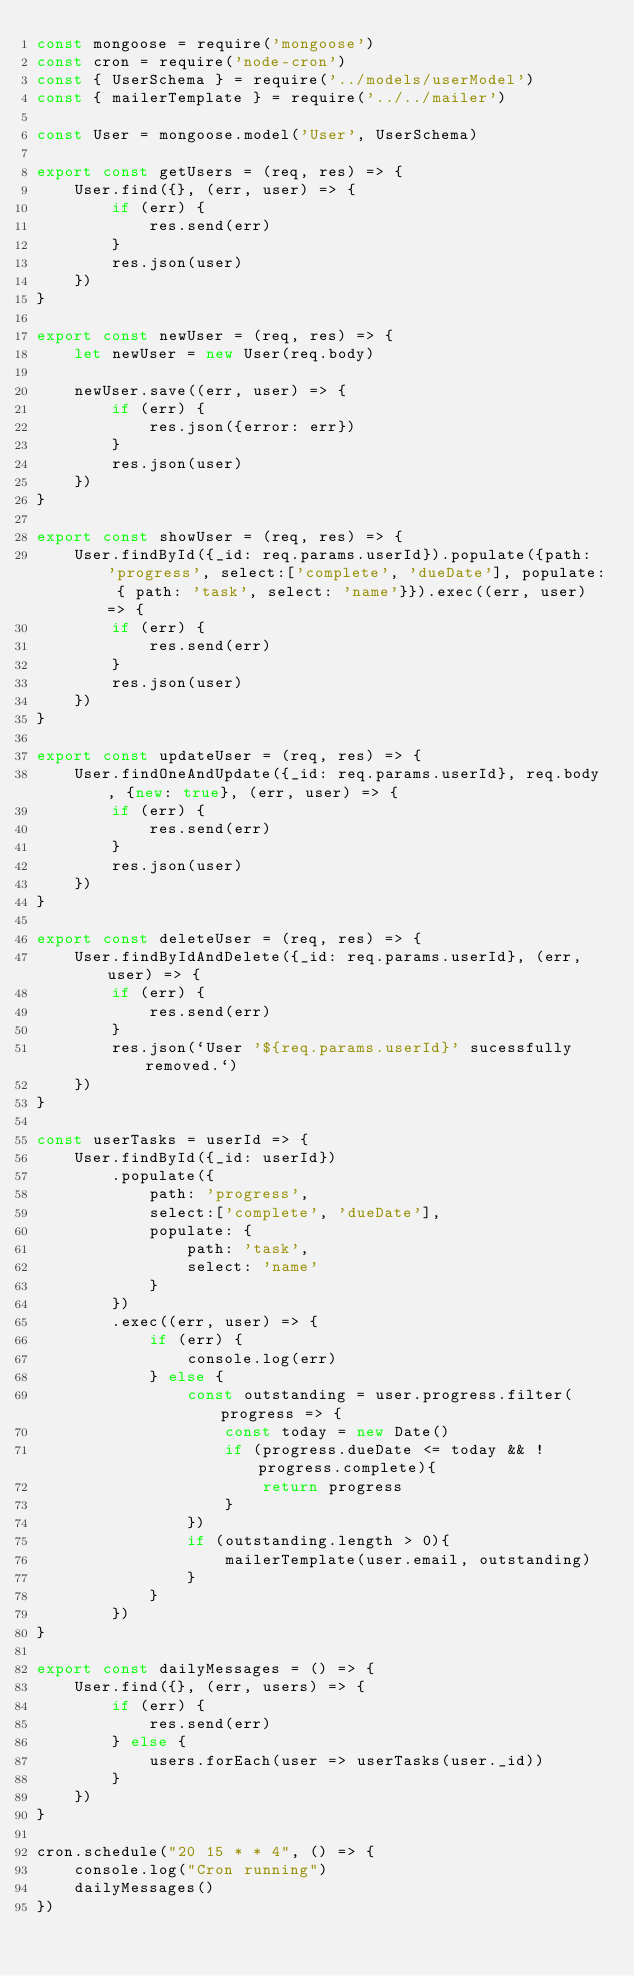<code> <loc_0><loc_0><loc_500><loc_500><_JavaScript_>const mongoose = require('mongoose')
const cron = require('node-cron')
const { UserSchema } = require('../models/userModel')
const { mailerTemplate } = require('../../mailer')

const User = mongoose.model('User', UserSchema)

export const getUsers = (req, res) => {
    User.find({}, (err, user) => {
        if (err) {
            res.send(err)
        }
        res.json(user)
    })
}

export const newUser = (req, res) => {
    let newUser = new User(req.body)

    newUser.save((err, user) => {
        if (err) {
            res.json({error: err})
        }
        res.json(user)
    })
}

export const showUser = (req, res) => {
    User.findById({_id: req.params.userId}).populate({path: 'progress', select:['complete', 'dueDate'], populate: { path: 'task', select: 'name'}}).exec((err, user) => {
        if (err) {
            res.send(err)
        }
        res.json(user)
    })
}

export const updateUser = (req, res) => {
    User.findOneAndUpdate({_id: req.params.userId}, req.body, {new: true}, (err, user) => {
        if (err) {
            res.send(err)
        }
        res.json(user)
    })
}

export const deleteUser = (req, res) => {
    User.findByIdAndDelete({_id: req.params.userId}, (err, user) => {
        if (err) {
            res.send(err)
        }
        res.json(`User '${req.params.userId}' sucessfully removed.`)
    })
}

const userTasks = userId => {
    User.findById({_id: userId})
        .populate({
            path: 'progress', 
            select:['complete', 'dueDate'], 
            populate: { 
                path: 'task', 
                select: 'name'
            }
        })
        .exec((err, user) => {
            if (err) {
                console.log(err)
            } else {
                const outstanding = user.progress.filter(progress => {
                    const today = new Date()
                    if (progress.dueDate <= today && !progress.complete){
                        return progress
                    }
                })
                if (outstanding.length > 0){
                    mailerTemplate(user.email, outstanding)
                }
            }
        })
}

export const dailyMessages = () => {
    User.find({}, (err, users) => {
        if (err) {
            res.send(err)
        } else {
            users.forEach(user => userTasks(user._id))
        }
    })
}

cron.schedule("20 15 * * 4", () => {
    console.log("Cron running")
    dailyMessages()
})</code> 